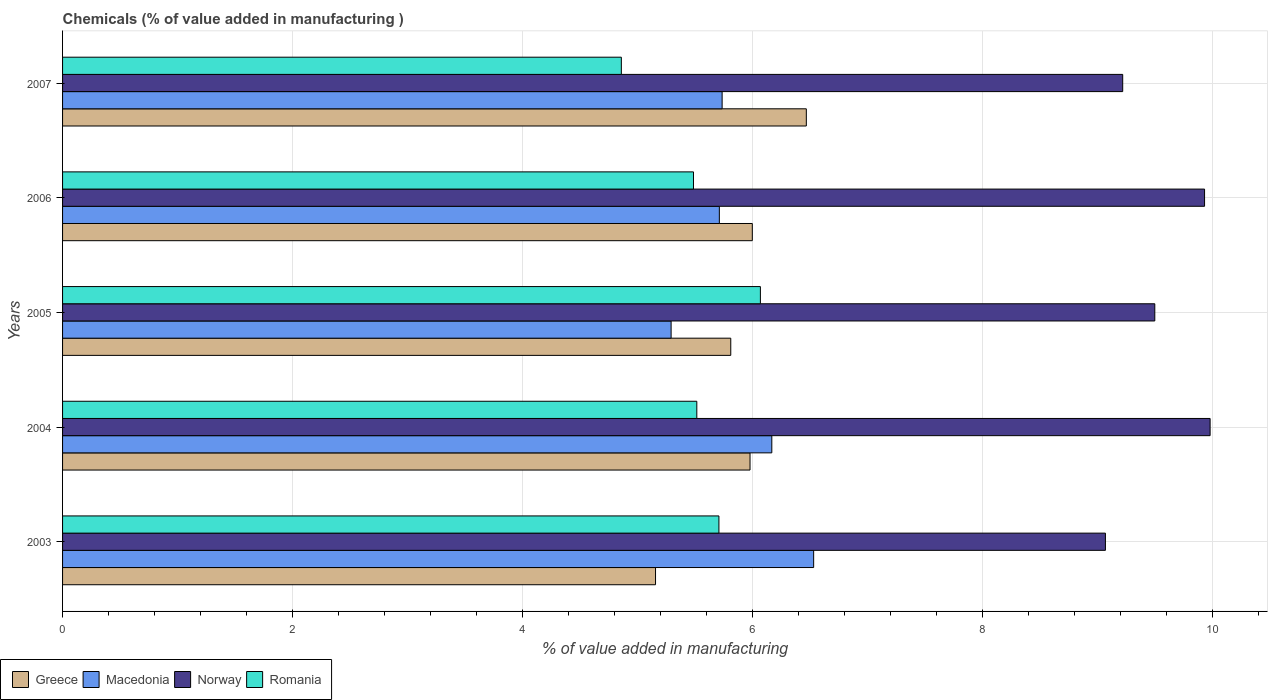How many different coloured bars are there?
Keep it short and to the point. 4. How many groups of bars are there?
Offer a terse response. 5. Are the number of bars per tick equal to the number of legend labels?
Offer a very short reply. Yes. Are the number of bars on each tick of the Y-axis equal?
Your answer should be very brief. Yes. What is the value added in manufacturing chemicals in Macedonia in 2003?
Your response must be concise. 6.53. Across all years, what is the maximum value added in manufacturing chemicals in Macedonia?
Provide a short and direct response. 6.53. Across all years, what is the minimum value added in manufacturing chemicals in Macedonia?
Offer a terse response. 5.29. In which year was the value added in manufacturing chemicals in Norway maximum?
Keep it short and to the point. 2004. What is the total value added in manufacturing chemicals in Romania in the graph?
Your answer should be compact. 27.63. What is the difference between the value added in manufacturing chemicals in Romania in 2003 and that in 2006?
Give a very brief answer. 0.22. What is the difference between the value added in manufacturing chemicals in Romania in 2006 and the value added in manufacturing chemicals in Greece in 2007?
Ensure brevity in your answer.  -0.98. What is the average value added in manufacturing chemicals in Greece per year?
Your response must be concise. 5.88. In the year 2005, what is the difference between the value added in manufacturing chemicals in Macedonia and value added in manufacturing chemicals in Greece?
Make the answer very short. -0.52. In how many years, is the value added in manufacturing chemicals in Macedonia greater than 6.4 %?
Ensure brevity in your answer.  1. What is the ratio of the value added in manufacturing chemicals in Macedonia in 2005 to that in 2007?
Your answer should be compact. 0.92. Is the difference between the value added in manufacturing chemicals in Macedonia in 2004 and 2005 greater than the difference between the value added in manufacturing chemicals in Greece in 2004 and 2005?
Offer a terse response. Yes. What is the difference between the highest and the second highest value added in manufacturing chemicals in Macedonia?
Your answer should be compact. 0.36. What is the difference between the highest and the lowest value added in manufacturing chemicals in Romania?
Your answer should be very brief. 1.21. In how many years, is the value added in manufacturing chemicals in Greece greater than the average value added in manufacturing chemicals in Greece taken over all years?
Your answer should be compact. 3. Is it the case that in every year, the sum of the value added in manufacturing chemicals in Greece and value added in manufacturing chemicals in Macedonia is greater than the sum of value added in manufacturing chemicals in Romania and value added in manufacturing chemicals in Norway?
Provide a short and direct response. No. What does the 3rd bar from the bottom in 2003 represents?
Make the answer very short. Norway. Are all the bars in the graph horizontal?
Provide a succinct answer. Yes. How many years are there in the graph?
Your answer should be compact. 5. What is the difference between two consecutive major ticks on the X-axis?
Keep it short and to the point. 2. Does the graph contain any zero values?
Offer a very short reply. No. Where does the legend appear in the graph?
Offer a terse response. Bottom left. How many legend labels are there?
Offer a terse response. 4. What is the title of the graph?
Your answer should be very brief. Chemicals (% of value added in manufacturing ). Does "Haiti" appear as one of the legend labels in the graph?
Your answer should be very brief. No. What is the label or title of the X-axis?
Your answer should be very brief. % of value added in manufacturing. What is the % of value added in manufacturing in Greece in 2003?
Your answer should be very brief. 5.16. What is the % of value added in manufacturing in Macedonia in 2003?
Your answer should be very brief. 6.53. What is the % of value added in manufacturing in Norway in 2003?
Your answer should be very brief. 9.07. What is the % of value added in manufacturing of Romania in 2003?
Provide a short and direct response. 5.71. What is the % of value added in manufacturing in Greece in 2004?
Keep it short and to the point. 5.98. What is the % of value added in manufacturing of Macedonia in 2004?
Your answer should be very brief. 6.17. What is the % of value added in manufacturing in Norway in 2004?
Offer a very short reply. 9.98. What is the % of value added in manufacturing in Romania in 2004?
Keep it short and to the point. 5.51. What is the % of value added in manufacturing of Greece in 2005?
Make the answer very short. 5.81. What is the % of value added in manufacturing of Macedonia in 2005?
Your response must be concise. 5.29. What is the % of value added in manufacturing in Norway in 2005?
Offer a terse response. 9.5. What is the % of value added in manufacturing of Romania in 2005?
Offer a terse response. 6.07. What is the % of value added in manufacturing in Greece in 2006?
Ensure brevity in your answer.  6. What is the % of value added in manufacturing in Macedonia in 2006?
Offer a terse response. 5.71. What is the % of value added in manufacturing in Norway in 2006?
Provide a succinct answer. 9.93. What is the % of value added in manufacturing of Romania in 2006?
Your answer should be compact. 5.49. What is the % of value added in manufacturing in Greece in 2007?
Your answer should be compact. 6.47. What is the % of value added in manufacturing of Macedonia in 2007?
Your response must be concise. 5.73. What is the % of value added in manufacturing of Norway in 2007?
Keep it short and to the point. 9.22. What is the % of value added in manufacturing in Romania in 2007?
Keep it short and to the point. 4.86. Across all years, what is the maximum % of value added in manufacturing in Greece?
Your answer should be compact. 6.47. Across all years, what is the maximum % of value added in manufacturing of Macedonia?
Your answer should be very brief. 6.53. Across all years, what is the maximum % of value added in manufacturing in Norway?
Ensure brevity in your answer.  9.98. Across all years, what is the maximum % of value added in manufacturing of Romania?
Provide a short and direct response. 6.07. Across all years, what is the minimum % of value added in manufacturing in Greece?
Your answer should be compact. 5.16. Across all years, what is the minimum % of value added in manufacturing in Macedonia?
Your answer should be compact. 5.29. Across all years, what is the minimum % of value added in manufacturing in Norway?
Offer a very short reply. 9.07. Across all years, what is the minimum % of value added in manufacturing of Romania?
Make the answer very short. 4.86. What is the total % of value added in manufacturing in Greece in the graph?
Ensure brevity in your answer.  29.4. What is the total % of value added in manufacturing of Macedonia in the graph?
Provide a succinct answer. 29.43. What is the total % of value added in manufacturing of Norway in the graph?
Keep it short and to the point. 47.69. What is the total % of value added in manufacturing in Romania in the graph?
Give a very brief answer. 27.63. What is the difference between the % of value added in manufacturing of Greece in 2003 and that in 2004?
Ensure brevity in your answer.  -0.82. What is the difference between the % of value added in manufacturing in Macedonia in 2003 and that in 2004?
Make the answer very short. 0.36. What is the difference between the % of value added in manufacturing of Norway in 2003 and that in 2004?
Your answer should be very brief. -0.91. What is the difference between the % of value added in manufacturing of Romania in 2003 and that in 2004?
Offer a terse response. 0.19. What is the difference between the % of value added in manufacturing in Greece in 2003 and that in 2005?
Make the answer very short. -0.65. What is the difference between the % of value added in manufacturing of Macedonia in 2003 and that in 2005?
Offer a terse response. 1.24. What is the difference between the % of value added in manufacturing in Norway in 2003 and that in 2005?
Your answer should be very brief. -0.43. What is the difference between the % of value added in manufacturing of Romania in 2003 and that in 2005?
Provide a succinct answer. -0.36. What is the difference between the % of value added in manufacturing in Greece in 2003 and that in 2006?
Ensure brevity in your answer.  -0.84. What is the difference between the % of value added in manufacturing in Macedonia in 2003 and that in 2006?
Ensure brevity in your answer.  0.82. What is the difference between the % of value added in manufacturing in Norway in 2003 and that in 2006?
Give a very brief answer. -0.86. What is the difference between the % of value added in manufacturing of Romania in 2003 and that in 2006?
Provide a succinct answer. 0.22. What is the difference between the % of value added in manufacturing in Greece in 2003 and that in 2007?
Make the answer very short. -1.31. What is the difference between the % of value added in manufacturing of Macedonia in 2003 and that in 2007?
Keep it short and to the point. 0.8. What is the difference between the % of value added in manufacturing of Norway in 2003 and that in 2007?
Give a very brief answer. -0.15. What is the difference between the % of value added in manufacturing of Romania in 2003 and that in 2007?
Offer a terse response. 0.85. What is the difference between the % of value added in manufacturing in Greece in 2004 and that in 2005?
Your answer should be compact. 0.17. What is the difference between the % of value added in manufacturing in Macedonia in 2004 and that in 2005?
Your answer should be very brief. 0.88. What is the difference between the % of value added in manufacturing of Norway in 2004 and that in 2005?
Offer a terse response. 0.48. What is the difference between the % of value added in manufacturing of Romania in 2004 and that in 2005?
Keep it short and to the point. -0.55. What is the difference between the % of value added in manufacturing in Greece in 2004 and that in 2006?
Make the answer very short. -0.02. What is the difference between the % of value added in manufacturing in Macedonia in 2004 and that in 2006?
Provide a short and direct response. 0.46. What is the difference between the % of value added in manufacturing in Norway in 2004 and that in 2006?
Give a very brief answer. 0.05. What is the difference between the % of value added in manufacturing in Romania in 2004 and that in 2006?
Offer a terse response. 0.03. What is the difference between the % of value added in manufacturing in Greece in 2004 and that in 2007?
Offer a very short reply. -0.49. What is the difference between the % of value added in manufacturing in Macedonia in 2004 and that in 2007?
Your answer should be compact. 0.43. What is the difference between the % of value added in manufacturing of Norway in 2004 and that in 2007?
Your response must be concise. 0.76. What is the difference between the % of value added in manufacturing in Romania in 2004 and that in 2007?
Offer a very short reply. 0.66. What is the difference between the % of value added in manufacturing of Greece in 2005 and that in 2006?
Offer a very short reply. -0.19. What is the difference between the % of value added in manufacturing in Macedonia in 2005 and that in 2006?
Your answer should be compact. -0.42. What is the difference between the % of value added in manufacturing of Norway in 2005 and that in 2006?
Offer a terse response. -0.43. What is the difference between the % of value added in manufacturing in Romania in 2005 and that in 2006?
Offer a terse response. 0.58. What is the difference between the % of value added in manufacturing of Greece in 2005 and that in 2007?
Provide a short and direct response. -0.66. What is the difference between the % of value added in manufacturing of Macedonia in 2005 and that in 2007?
Your answer should be compact. -0.44. What is the difference between the % of value added in manufacturing of Norway in 2005 and that in 2007?
Provide a short and direct response. 0.28. What is the difference between the % of value added in manufacturing in Romania in 2005 and that in 2007?
Offer a very short reply. 1.21. What is the difference between the % of value added in manufacturing in Greece in 2006 and that in 2007?
Keep it short and to the point. -0.47. What is the difference between the % of value added in manufacturing of Macedonia in 2006 and that in 2007?
Your answer should be very brief. -0.02. What is the difference between the % of value added in manufacturing of Norway in 2006 and that in 2007?
Provide a short and direct response. 0.71. What is the difference between the % of value added in manufacturing of Romania in 2006 and that in 2007?
Provide a short and direct response. 0.63. What is the difference between the % of value added in manufacturing in Greece in 2003 and the % of value added in manufacturing in Macedonia in 2004?
Give a very brief answer. -1.01. What is the difference between the % of value added in manufacturing of Greece in 2003 and the % of value added in manufacturing of Norway in 2004?
Make the answer very short. -4.82. What is the difference between the % of value added in manufacturing in Greece in 2003 and the % of value added in manufacturing in Romania in 2004?
Ensure brevity in your answer.  -0.36. What is the difference between the % of value added in manufacturing of Macedonia in 2003 and the % of value added in manufacturing of Norway in 2004?
Your answer should be very brief. -3.45. What is the difference between the % of value added in manufacturing of Macedonia in 2003 and the % of value added in manufacturing of Romania in 2004?
Keep it short and to the point. 1.02. What is the difference between the % of value added in manufacturing of Norway in 2003 and the % of value added in manufacturing of Romania in 2004?
Your answer should be very brief. 3.55. What is the difference between the % of value added in manufacturing of Greece in 2003 and the % of value added in manufacturing of Macedonia in 2005?
Your answer should be very brief. -0.14. What is the difference between the % of value added in manufacturing in Greece in 2003 and the % of value added in manufacturing in Norway in 2005?
Give a very brief answer. -4.34. What is the difference between the % of value added in manufacturing in Greece in 2003 and the % of value added in manufacturing in Romania in 2005?
Keep it short and to the point. -0.91. What is the difference between the % of value added in manufacturing of Macedonia in 2003 and the % of value added in manufacturing of Norway in 2005?
Keep it short and to the point. -2.97. What is the difference between the % of value added in manufacturing in Macedonia in 2003 and the % of value added in manufacturing in Romania in 2005?
Offer a terse response. 0.46. What is the difference between the % of value added in manufacturing of Norway in 2003 and the % of value added in manufacturing of Romania in 2005?
Your response must be concise. 3. What is the difference between the % of value added in manufacturing of Greece in 2003 and the % of value added in manufacturing of Macedonia in 2006?
Your response must be concise. -0.55. What is the difference between the % of value added in manufacturing of Greece in 2003 and the % of value added in manufacturing of Norway in 2006?
Provide a short and direct response. -4.77. What is the difference between the % of value added in manufacturing in Greece in 2003 and the % of value added in manufacturing in Romania in 2006?
Make the answer very short. -0.33. What is the difference between the % of value added in manufacturing in Macedonia in 2003 and the % of value added in manufacturing in Norway in 2006?
Provide a succinct answer. -3.4. What is the difference between the % of value added in manufacturing of Macedonia in 2003 and the % of value added in manufacturing of Romania in 2006?
Make the answer very short. 1.04. What is the difference between the % of value added in manufacturing of Norway in 2003 and the % of value added in manufacturing of Romania in 2006?
Make the answer very short. 3.58. What is the difference between the % of value added in manufacturing in Greece in 2003 and the % of value added in manufacturing in Macedonia in 2007?
Make the answer very short. -0.58. What is the difference between the % of value added in manufacturing of Greece in 2003 and the % of value added in manufacturing of Norway in 2007?
Make the answer very short. -4.06. What is the difference between the % of value added in manufacturing in Greece in 2003 and the % of value added in manufacturing in Romania in 2007?
Ensure brevity in your answer.  0.3. What is the difference between the % of value added in manufacturing in Macedonia in 2003 and the % of value added in manufacturing in Norway in 2007?
Your answer should be compact. -2.69. What is the difference between the % of value added in manufacturing in Macedonia in 2003 and the % of value added in manufacturing in Romania in 2007?
Provide a short and direct response. 1.67. What is the difference between the % of value added in manufacturing of Norway in 2003 and the % of value added in manufacturing of Romania in 2007?
Provide a succinct answer. 4.21. What is the difference between the % of value added in manufacturing of Greece in 2004 and the % of value added in manufacturing of Macedonia in 2005?
Provide a succinct answer. 0.69. What is the difference between the % of value added in manufacturing of Greece in 2004 and the % of value added in manufacturing of Norway in 2005?
Ensure brevity in your answer.  -3.52. What is the difference between the % of value added in manufacturing in Greece in 2004 and the % of value added in manufacturing in Romania in 2005?
Offer a very short reply. -0.09. What is the difference between the % of value added in manufacturing in Macedonia in 2004 and the % of value added in manufacturing in Norway in 2005?
Give a very brief answer. -3.33. What is the difference between the % of value added in manufacturing of Macedonia in 2004 and the % of value added in manufacturing of Romania in 2005?
Make the answer very short. 0.1. What is the difference between the % of value added in manufacturing of Norway in 2004 and the % of value added in manufacturing of Romania in 2005?
Offer a terse response. 3.91. What is the difference between the % of value added in manufacturing of Greece in 2004 and the % of value added in manufacturing of Macedonia in 2006?
Provide a succinct answer. 0.27. What is the difference between the % of value added in manufacturing in Greece in 2004 and the % of value added in manufacturing in Norway in 2006?
Give a very brief answer. -3.95. What is the difference between the % of value added in manufacturing of Greece in 2004 and the % of value added in manufacturing of Romania in 2006?
Ensure brevity in your answer.  0.49. What is the difference between the % of value added in manufacturing of Macedonia in 2004 and the % of value added in manufacturing of Norway in 2006?
Make the answer very short. -3.76. What is the difference between the % of value added in manufacturing in Macedonia in 2004 and the % of value added in manufacturing in Romania in 2006?
Your answer should be very brief. 0.68. What is the difference between the % of value added in manufacturing of Norway in 2004 and the % of value added in manufacturing of Romania in 2006?
Keep it short and to the point. 4.49. What is the difference between the % of value added in manufacturing in Greece in 2004 and the % of value added in manufacturing in Macedonia in 2007?
Your answer should be very brief. 0.24. What is the difference between the % of value added in manufacturing in Greece in 2004 and the % of value added in manufacturing in Norway in 2007?
Offer a terse response. -3.24. What is the difference between the % of value added in manufacturing in Greece in 2004 and the % of value added in manufacturing in Romania in 2007?
Give a very brief answer. 1.12. What is the difference between the % of value added in manufacturing in Macedonia in 2004 and the % of value added in manufacturing in Norway in 2007?
Ensure brevity in your answer.  -3.05. What is the difference between the % of value added in manufacturing of Macedonia in 2004 and the % of value added in manufacturing of Romania in 2007?
Your answer should be compact. 1.31. What is the difference between the % of value added in manufacturing in Norway in 2004 and the % of value added in manufacturing in Romania in 2007?
Provide a short and direct response. 5.12. What is the difference between the % of value added in manufacturing in Greece in 2005 and the % of value added in manufacturing in Macedonia in 2006?
Your response must be concise. 0.1. What is the difference between the % of value added in manufacturing in Greece in 2005 and the % of value added in manufacturing in Norway in 2006?
Provide a short and direct response. -4.12. What is the difference between the % of value added in manufacturing of Greece in 2005 and the % of value added in manufacturing of Romania in 2006?
Ensure brevity in your answer.  0.32. What is the difference between the % of value added in manufacturing in Macedonia in 2005 and the % of value added in manufacturing in Norway in 2006?
Your answer should be compact. -4.64. What is the difference between the % of value added in manufacturing in Macedonia in 2005 and the % of value added in manufacturing in Romania in 2006?
Offer a very short reply. -0.19. What is the difference between the % of value added in manufacturing in Norway in 2005 and the % of value added in manufacturing in Romania in 2006?
Ensure brevity in your answer.  4.01. What is the difference between the % of value added in manufacturing of Greece in 2005 and the % of value added in manufacturing of Macedonia in 2007?
Offer a terse response. 0.07. What is the difference between the % of value added in manufacturing in Greece in 2005 and the % of value added in manufacturing in Norway in 2007?
Provide a succinct answer. -3.41. What is the difference between the % of value added in manufacturing of Greece in 2005 and the % of value added in manufacturing of Romania in 2007?
Your response must be concise. 0.95. What is the difference between the % of value added in manufacturing in Macedonia in 2005 and the % of value added in manufacturing in Norway in 2007?
Provide a short and direct response. -3.93. What is the difference between the % of value added in manufacturing of Macedonia in 2005 and the % of value added in manufacturing of Romania in 2007?
Make the answer very short. 0.43. What is the difference between the % of value added in manufacturing in Norway in 2005 and the % of value added in manufacturing in Romania in 2007?
Provide a succinct answer. 4.64. What is the difference between the % of value added in manufacturing of Greece in 2006 and the % of value added in manufacturing of Macedonia in 2007?
Make the answer very short. 0.26. What is the difference between the % of value added in manufacturing of Greece in 2006 and the % of value added in manufacturing of Norway in 2007?
Provide a short and direct response. -3.22. What is the difference between the % of value added in manufacturing in Greece in 2006 and the % of value added in manufacturing in Romania in 2007?
Keep it short and to the point. 1.14. What is the difference between the % of value added in manufacturing in Macedonia in 2006 and the % of value added in manufacturing in Norway in 2007?
Provide a short and direct response. -3.51. What is the difference between the % of value added in manufacturing of Macedonia in 2006 and the % of value added in manufacturing of Romania in 2007?
Provide a succinct answer. 0.85. What is the difference between the % of value added in manufacturing in Norway in 2006 and the % of value added in manufacturing in Romania in 2007?
Provide a succinct answer. 5.07. What is the average % of value added in manufacturing in Greece per year?
Offer a very short reply. 5.88. What is the average % of value added in manufacturing in Macedonia per year?
Provide a succinct answer. 5.89. What is the average % of value added in manufacturing of Norway per year?
Provide a short and direct response. 9.54. What is the average % of value added in manufacturing in Romania per year?
Your answer should be very brief. 5.53. In the year 2003, what is the difference between the % of value added in manufacturing of Greece and % of value added in manufacturing of Macedonia?
Your answer should be very brief. -1.37. In the year 2003, what is the difference between the % of value added in manufacturing of Greece and % of value added in manufacturing of Norway?
Provide a short and direct response. -3.91. In the year 2003, what is the difference between the % of value added in manufacturing of Greece and % of value added in manufacturing of Romania?
Your answer should be very brief. -0.55. In the year 2003, what is the difference between the % of value added in manufacturing of Macedonia and % of value added in manufacturing of Norway?
Provide a succinct answer. -2.54. In the year 2003, what is the difference between the % of value added in manufacturing in Macedonia and % of value added in manufacturing in Romania?
Give a very brief answer. 0.82. In the year 2003, what is the difference between the % of value added in manufacturing in Norway and % of value added in manufacturing in Romania?
Provide a succinct answer. 3.36. In the year 2004, what is the difference between the % of value added in manufacturing in Greece and % of value added in manufacturing in Macedonia?
Your answer should be compact. -0.19. In the year 2004, what is the difference between the % of value added in manufacturing of Greece and % of value added in manufacturing of Norway?
Provide a succinct answer. -4. In the year 2004, what is the difference between the % of value added in manufacturing of Greece and % of value added in manufacturing of Romania?
Make the answer very short. 0.46. In the year 2004, what is the difference between the % of value added in manufacturing in Macedonia and % of value added in manufacturing in Norway?
Your answer should be very brief. -3.81. In the year 2004, what is the difference between the % of value added in manufacturing of Macedonia and % of value added in manufacturing of Romania?
Give a very brief answer. 0.65. In the year 2004, what is the difference between the % of value added in manufacturing of Norway and % of value added in manufacturing of Romania?
Give a very brief answer. 4.46. In the year 2005, what is the difference between the % of value added in manufacturing in Greece and % of value added in manufacturing in Macedonia?
Ensure brevity in your answer.  0.52. In the year 2005, what is the difference between the % of value added in manufacturing of Greece and % of value added in manufacturing of Norway?
Keep it short and to the point. -3.69. In the year 2005, what is the difference between the % of value added in manufacturing of Greece and % of value added in manufacturing of Romania?
Offer a very short reply. -0.26. In the year 2005, what is the difference between the % of value added in manufacturing in Macedonia and % of value added in manufacturing in Norway?
Offer a very short reply. -4.21. In the year 2005, what is the difference between the % of value added in manufacturing of Macedonia and % of value added in manufacturing of Romania?
Your response must be concise. -0.78. In the year 2005, what is the difference between the % of value added in manufacturing in Norway and % of value added in manufacturing in Romania?
Offer a very short reply. 3.43. In the year 2006, what is the difference between the % of value added in manufacturing of Greece and % of value added in manufacturing of Macedonia?
Ensure brevity in your answer.  0.29. In the year 2006, what is the difference between the % of value added in manufacturing in Greece and % of value added in manufacturing in Norway?
Offer a terse response. -3.93. In the year 2006, what is the difference between the % of value added in manufacturing of Greece and % of value added in manufacturing of Romania?
Give a very brief answer. 0.51. In the year 2006, what is the difference between the % of value added in manufacturing of Macedonia and % of value added in manufacturing of Norway?
Offer a terse response. -4.22. In the year 2006, what is the difference between the % of value added in manufacturing of Macedonia and % of value added in manufacturing of Romania?
Your response must be concise. 0.22. In the year 2006, what is the difference between the % of value added in manufacturing of Norway and % of value added in manufacturing of Romania?
Your answer should be very brief. 4.44. In the year 2007, what is the difference between the % of value added in manufacturing of Greece and % of value added in manufacturing of Macedonia?
Ensure brevity in your answer.  0.73. In the year 2007, what is the difference between the % of value added in manufacturing in Greece and % of value added in manufacturing in Norway?
Your response must be concise. -2.75. In the year 2007, what is the difference between the % of value added in manufacturing of Greece and % of value added in manufacturing of Romania?
Provide a succinct answer. 1.61. In the year 2007, what is the difference between the % of value added in manufacturing in Macedonia and % of value added in manufacturing in Norway?
Keep it short and to the point. -3.48. In the year 2007, what is the difference between the % of value added in manufacturing in Macedonia and % of value added in manufacturing in Romania?
Offer a terse response. 0.88. In the year 2007, what is the difference between the % of value added in manufacturing of Norway and % of value added in manufacturing of Romania?
Provide a succinct answer. 4.36. What is the ratio of the % of value added in manufacturing in Greece in 2003 to that in 2004?
Your response must be concise. 0.86. What is the ratio of the % of value added in manufacturing of Macedonia in 2003 to that in 2004?
Provide a succinct answer. 1.06. What is the ratio of the % of value added in manufacturing of Norway in 2003 to that in 2004?
Offer a terse response. 0.91. What is the ratio of the % of value added in manufacturing in Romania in 2003 to that in 2004?
Your answer should be compact. 1.03. What is the ratio of the % of value added in manufacturing in Greece in 2003 to that in 2005?
Your answer should be very brief. 0.89. What is the ratio of the % of value added in manufacturing in Macedonia in 2003 to that in 2005?
Your answer should be very brief. 1.23. What is the ratio of the % of value added in manufacturing in Norway in 2003 to that in 2005?
Your answer should be compact. 0.95. What is the ratio of the % of value added in manufacturing in Romania in 2003 to that in 2005?
Your response must be concise. 0.94. What is the ratio of the % of value added in manufacturing of Greece in 2003 to that in 2006?
Offer a terse response. 0.86. What is the ratio of the % of value added in manufacturing of Macedonia in 2003 to that in 2006?
Make the answer very short. 1.14. What is the ratio of the % of value added in manufacturing in Norway in 2003 to that in 2006?
Keep it short and to the point. 0.91. What is the ratio of the % of value added in manufacturing in Romania in 2003 to that in 2006?
Provide a short and direct response. 1.04. What is the ratio of the % of value added in manufacturing of Greece in 2003 to that in 2007?
Offer a very short reply. 0.8. What is the ratio of the % of value added in manufacturing in Macedonia in 2003 to that in 2007?
Ensure brevity in your answer.  1.14. What is the ratio of the % of value added in manufacturing of Norway in 2003 to that in 2007?
Make the answer very short. 0.98. What is the ratio of the % of value added in manufacturing in Romania in 2003 to that in 2007?
Give a very brief answer. 1.17. What is the ratio of the % of value added in manufacturing in Greece in 2004 to that in 2005?
Make the answer very short. 1.03. What is the ratio of the % of value added in manufacturing in Macedonia in 2004 to that in 2005?
Make the answer very short. 1.17. What is the ratio of the % of value added in manufacturing of Norway in 2004 to that in 2005?
Your answer should be very brief. 1.05. What is the ratio of the % of value added in manufacturing of Romania in 2004 to that in 2005?
Your answer should be compact. 0.91. What is the ratio of the % of value added in manufacturing of Macedonia in 2004 to that in 2006?
Your answer should be compact. 1.08. What is the ratio of the % of value added in manufacturing of Greece in 2004 to that in 2007?
Your response must be concise. 0.92. What is the ratio of the % of value added in manufacturing of Macedonia in 2004 to that in 2007?
Your answer should be compact. 1.08. What is the ratio of the % of value added in manufacturing of Norway in 2004 to that in 2007?
Offer a very short reply. 1.08. What is the ratio of the % of value added in manufacturing in Romania in 2004 to that in 2007?
Make the answer very short. 1.14. What is the ratio of the % of value added in manufacturing in Greece in 2005 to that in 2006?
Your answer should be very brief. 0.97. What is the ratio of the % of value added in manufacturing of Macedonia in 2005 to that in 2006?
Keep it short and to the point. 0.93. What is the ratio of the % of value added in manufacturing of Norway in 2005 to that in 2006?
Make the answer very short. 0.96. What is the ratio of the % of value added in manufacturing of Romania in 2005 to that in 2006?
Offer a very short reply. 1.11. What is the ratio of the % of value added in manufacturing of Greece in 2005 to that in 2007?
Offer a terse response. 0.9. What is the ratio of the % of value added in manufacturing of Macedonia in 2005 to that in 2007?
Ensure brevity in your answer.  0.92. What is the ratio of the % of value added in manufacturing in Norway in 2005 to that in 2007?
Provide a succinct answer. 1.03. What is the ratio of the % of value added in manufacturing of Romania in 2005 to that in 2007?
Keep it short and to the point. 1.25. What is the ratio of the % of value added in manufacturing in Greece in 2006 to that in 2007?
Give a very brief answer. 0.93. What is the ratio of the % of value added in manufacturing in Norway in 2006 to that in 2007?
Your answer should be compact. 1.08. What is the ratio of the % of value added in manufacturing in Romania in 2006 to that in 2007?
Your answer should be compact. 1.13. What is the difference between the highest and the second highest % of value added in manufacturing in Greece?
Keep it short and to the point. 0.47. What is the difference between the highest and the second highest % of value added in manufacturing in Macedonia?
Ensure brevity in your answer.  0.36. What is the difference between the highest and the second highest % of value added in manufacturing in Norway?
Ensure brevity in your answer.  0.05. What is the difference between the highest and the second highest % of value added in manufacturing of Romania?
Provide a short and direct response. 0.36. What is the difference between the highest and the lowest % of value added in manufacturing of Greece?
Ensure brevity in your answer.  1.31. What is the difference between the highest and the lowest % of value added in manufacturing of Macedonia?
Your answer should be compact. 1.24. What is the difference between the highest and the lowest % of value added in manufacturing in Norway?
Keep it short and to the point. 0.91. What is the difference between the highest and the lowest % of value added in manufacturing of Romania?
Your answer should be very brief. 1.21. 